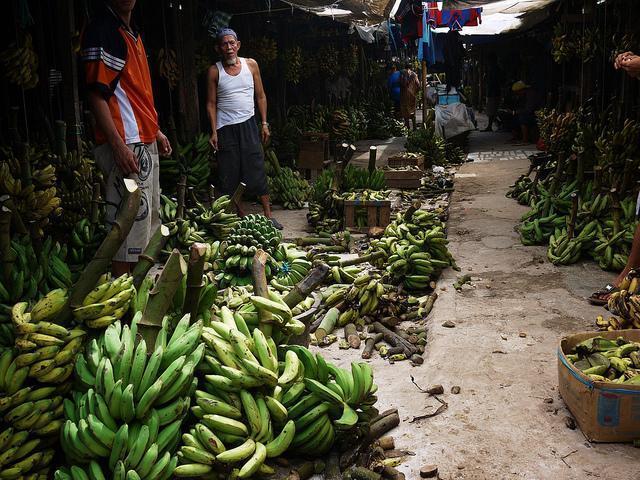How many people are there?
Give a very brief answer. 2. How many bananas are there?
Give a very brief answer. 3. 